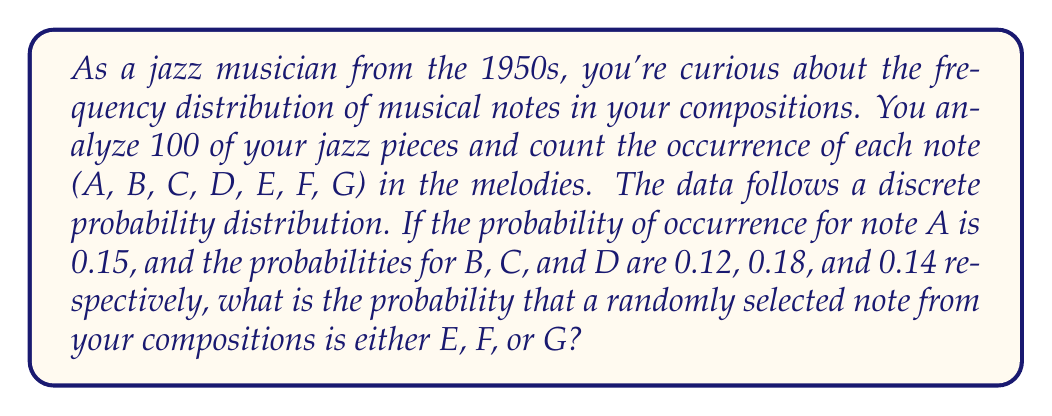Help me with this question. To solve this problem, we'll use the properties of probability distributions:

1) First, recall that the sum of all probabilities in a discrete probability distribution must equal 1.

2) We're given the probabilities for notes A, B, C, and D:
   $P(A) = 0.15$
   $P(B) = 0.12$
   $P(C) = 0.18$
   $P(D) = 0.14$

3) Let's sum these known probabilities:
   $0.15 + 0.12 + 0.18 + 0.14 = 0.59$

4) The remaining probability must be distributed among E, F, and G. We can find this by subtracting from 1:
   $1 - 0.59 = 0.41$

5) The question asks for the probability of selecting either E, F, or G. This is exactly the remaining probability we calculated.

6) Therefore, $P(E \text{ or } F \text{ or } G) = 0.41$

This approach uses the complement rule of probability: the probability of an event occurring is equal to 1 minus the probability of it not occurring. In this case, the probability of not selecting A, B, C, or D is equal to the probability of selecting E, F, or G.
Answer: The probability that a randomly selected note is either E, F, or G is 0.41. 